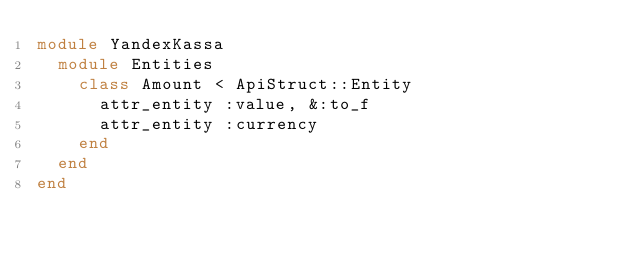Convert code to text. <code><loc_0><loc_0><loc_500><loc_500><_Ruby_>module YandexKassa
  module Entities
    class Amount < ApiStruct::Entity
      attr_entity :value, &:to_f
      attr_entity :currency
    end
  end
end</code> 